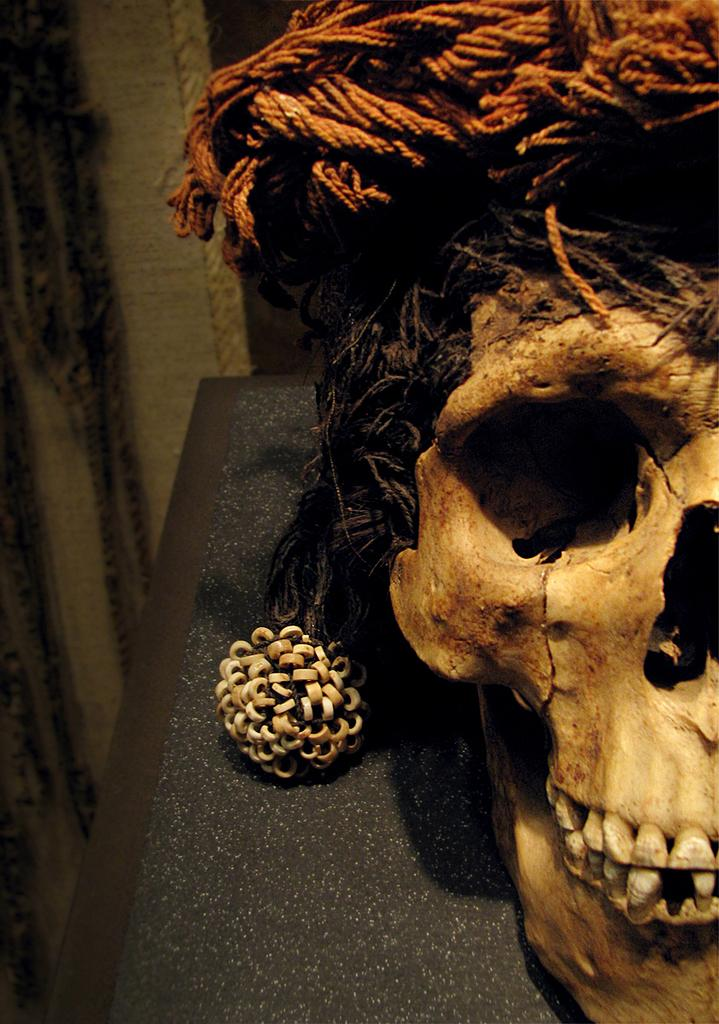What is the color of the skull in the image? The skull in the image is yellow-colored. Can you describe any other elements in the image besides the skull? Unfortunately, the provided facts do not specify any other elements in the image. What theory does the woman in the image propose about the skull? There is no woman present in the image, and therefore no theory can be proposed about the skull. 